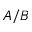<formula> <loc_0><loc_0><loc_500><loc_500>A / B</formula> 